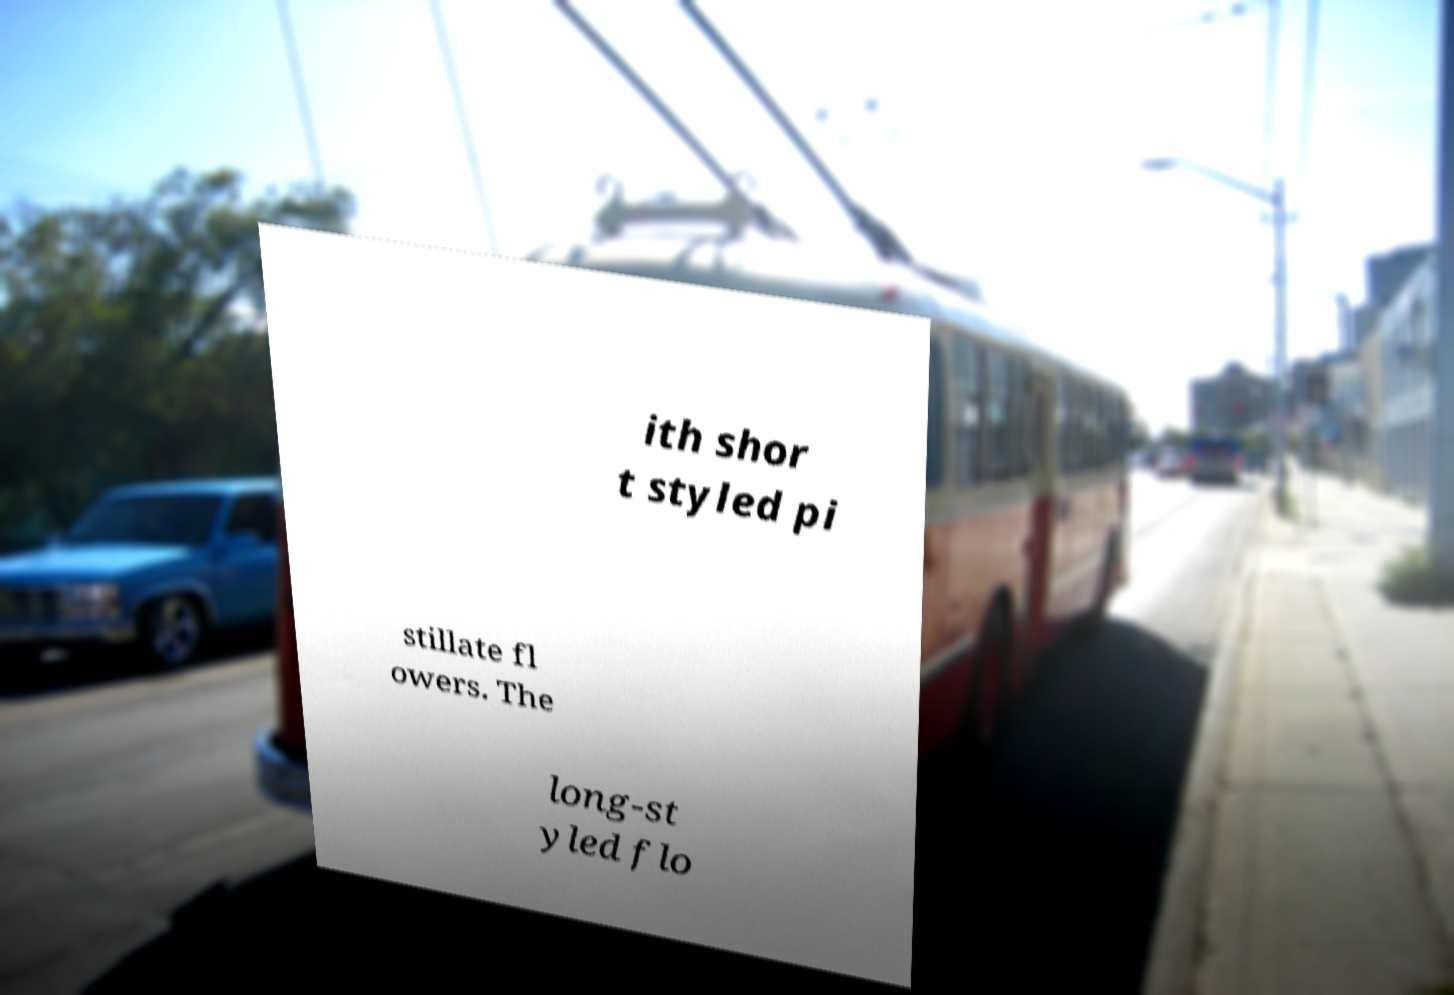Please read and relay the text visible in this image. What does it say? ith shor t styled pi stillate fl owers. The long-st yled flo 